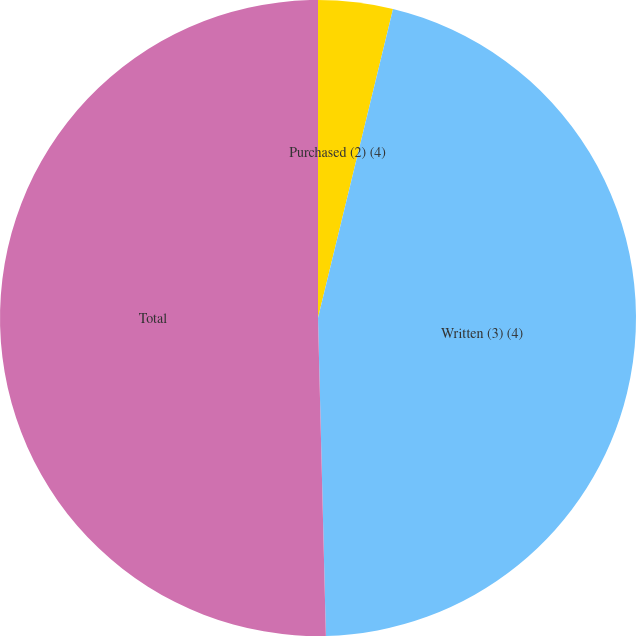Convert chart to OTSL. <chart><loc_0><loc_0><loc_500><loc_500><pie_chart><fcel>Purchased (2) (4)<fcel>Written (3) (4)<fcel>Total<nl><fcel>3.79%<fcel>45.81%<fcel>50.39%<nl></chart> 